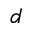Convert formula to latex. <formula><loc_0><loc_0><loc_500><loc_500>d</formula> 